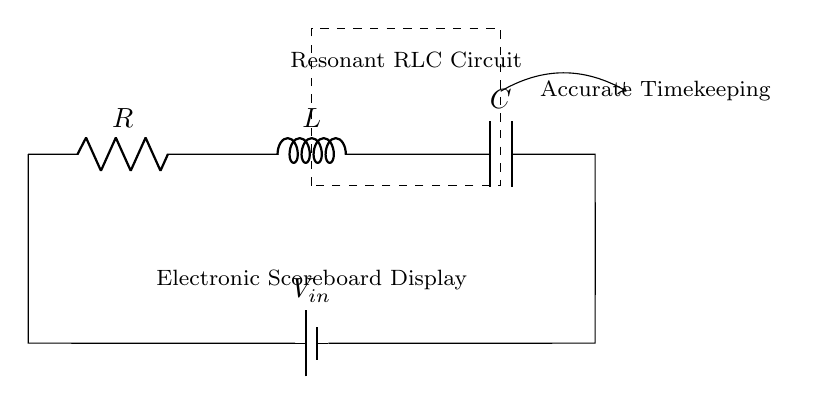What type of circuit is shown? The circuit is a Resonant RLC Circuit, indicated by the symbols for the Resistor, Inductor, and Capacitor.
Answer: Resonant RLC Circuit What components are in the circuit? The components visible in the circuit are a Resistor, an Inductor, and a Capacitor connected in series with a voltage source.
Answer: Resistor, Inductor, Capacitor What is the function of the RLC circuit in this diagram? The function of the RLC circuit in this context is to provide accurate timekeeping for the electronic scoreboard display, as noted in the label below the circuit.
Answer: Accurate Timekeeping How is the voltage source connected in the circuit? The voltage source is connected at the leftmost side of the circuit diagram, supplying voltage to the series arrangement of the components.
Answer: In series What is the role of the inductor in the RLC circuit? The inductor in an RLC circuit helps to manage the current flow, store energy in its magnetic field, and contributes to the circuit's resonance.
Answer: Store energy What happens at resonance in an RLC circuit? At resonance, the inductive and capacitive reactances cancel each other out, resulting in maximum current and allowing the circuit to oscillate at a particular frequency determined by the values of R, L, and C.
Answer: Maximum current 